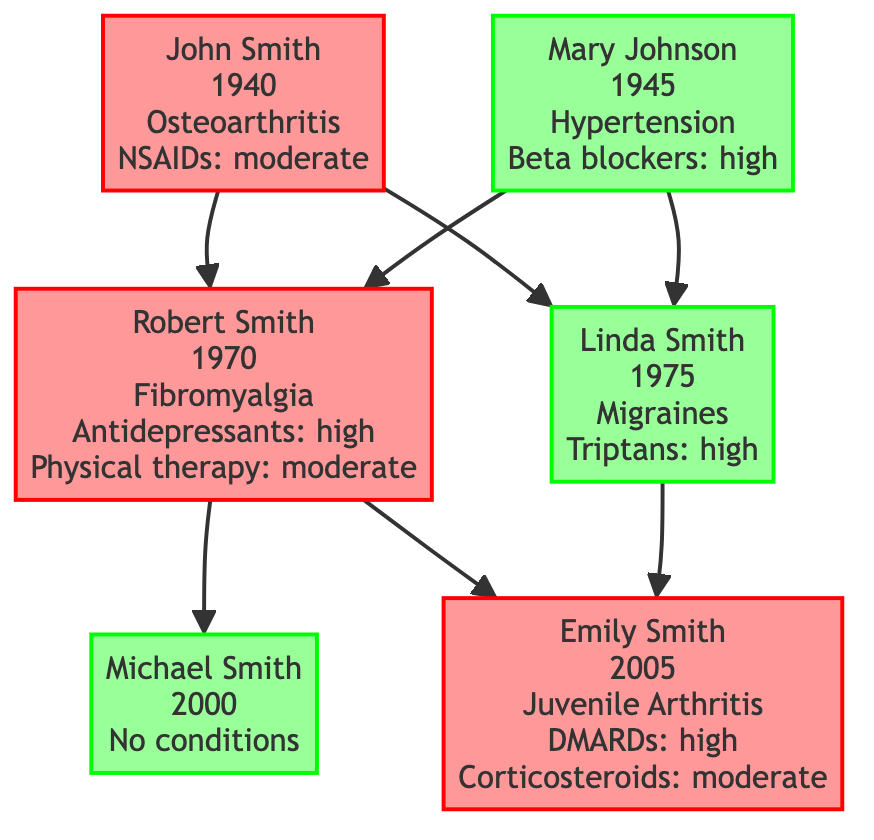What is the chronic condition of John Smith? The diagram indicates that John Smith has Osteoarthritis, which is noted under his name.
Answer: Osteoarthritis How many children does Robert Smith have? By examining the diagram, Robert Smith is shown to have two children: Michael Smith and Emily Smith, which can be counted directly from the connections originating from Robert Smith.
Answer: 2 What treatment was effective for Emily Smith? The diagram details that Emily Smith received DMARDs, which have a high effectiveness, and corticosteroids, which have moderate effectiveness; both treatments are listed under her health conditions.
Answer: DMARDs Who are the parents of Linda Smith? Linda Smith is shown to have John Smith and Mary Johnson as her parents in the relationships section of the diagram, which shows the connections to her from both.
Answer: John Smith and Mary Johnson Is there a family member with chronic pain who uses antidepressants? Looking at the diagram, Robert Smith is indicated as having chronic pain due to Fibromyalgia and is shown to use antidepressants, which are listed under his treatments.
Answer: Robert Smith What condition does Michael Smith have? The diagram states that Michael Smith has "No conditions," which is clearly indicated in his section as there are no chronic pain or other health conditions listed.
Answer: No conditions What is the effectiveness of the treatment for Fibromyalgia? The diagram specifies that Robert Smith, who has Fibromyalgia, uses antidepressants that are classified with high effectiveness and physical therapy which is classified with moderate effectiveness.
Answer: High Who experiences Juvenile Arthritis in the family? Emily Smith is identified as having Juvenile Arthritis in the diagram, which is explicitly stated in her information, along with the treatments she has received.
Answer: Emily Smith How is Linda Smith related to Michael Smith? The diagram illustrates that Linda Smith is the mother of Emily Smith, and since Robert Smith (who is Michael's father) is also Emily's father, the relationship shows that Michael Smith and Emily Smith are siblings. Therefore, Linda Smith is Michael's mother.
Answer: Mother 